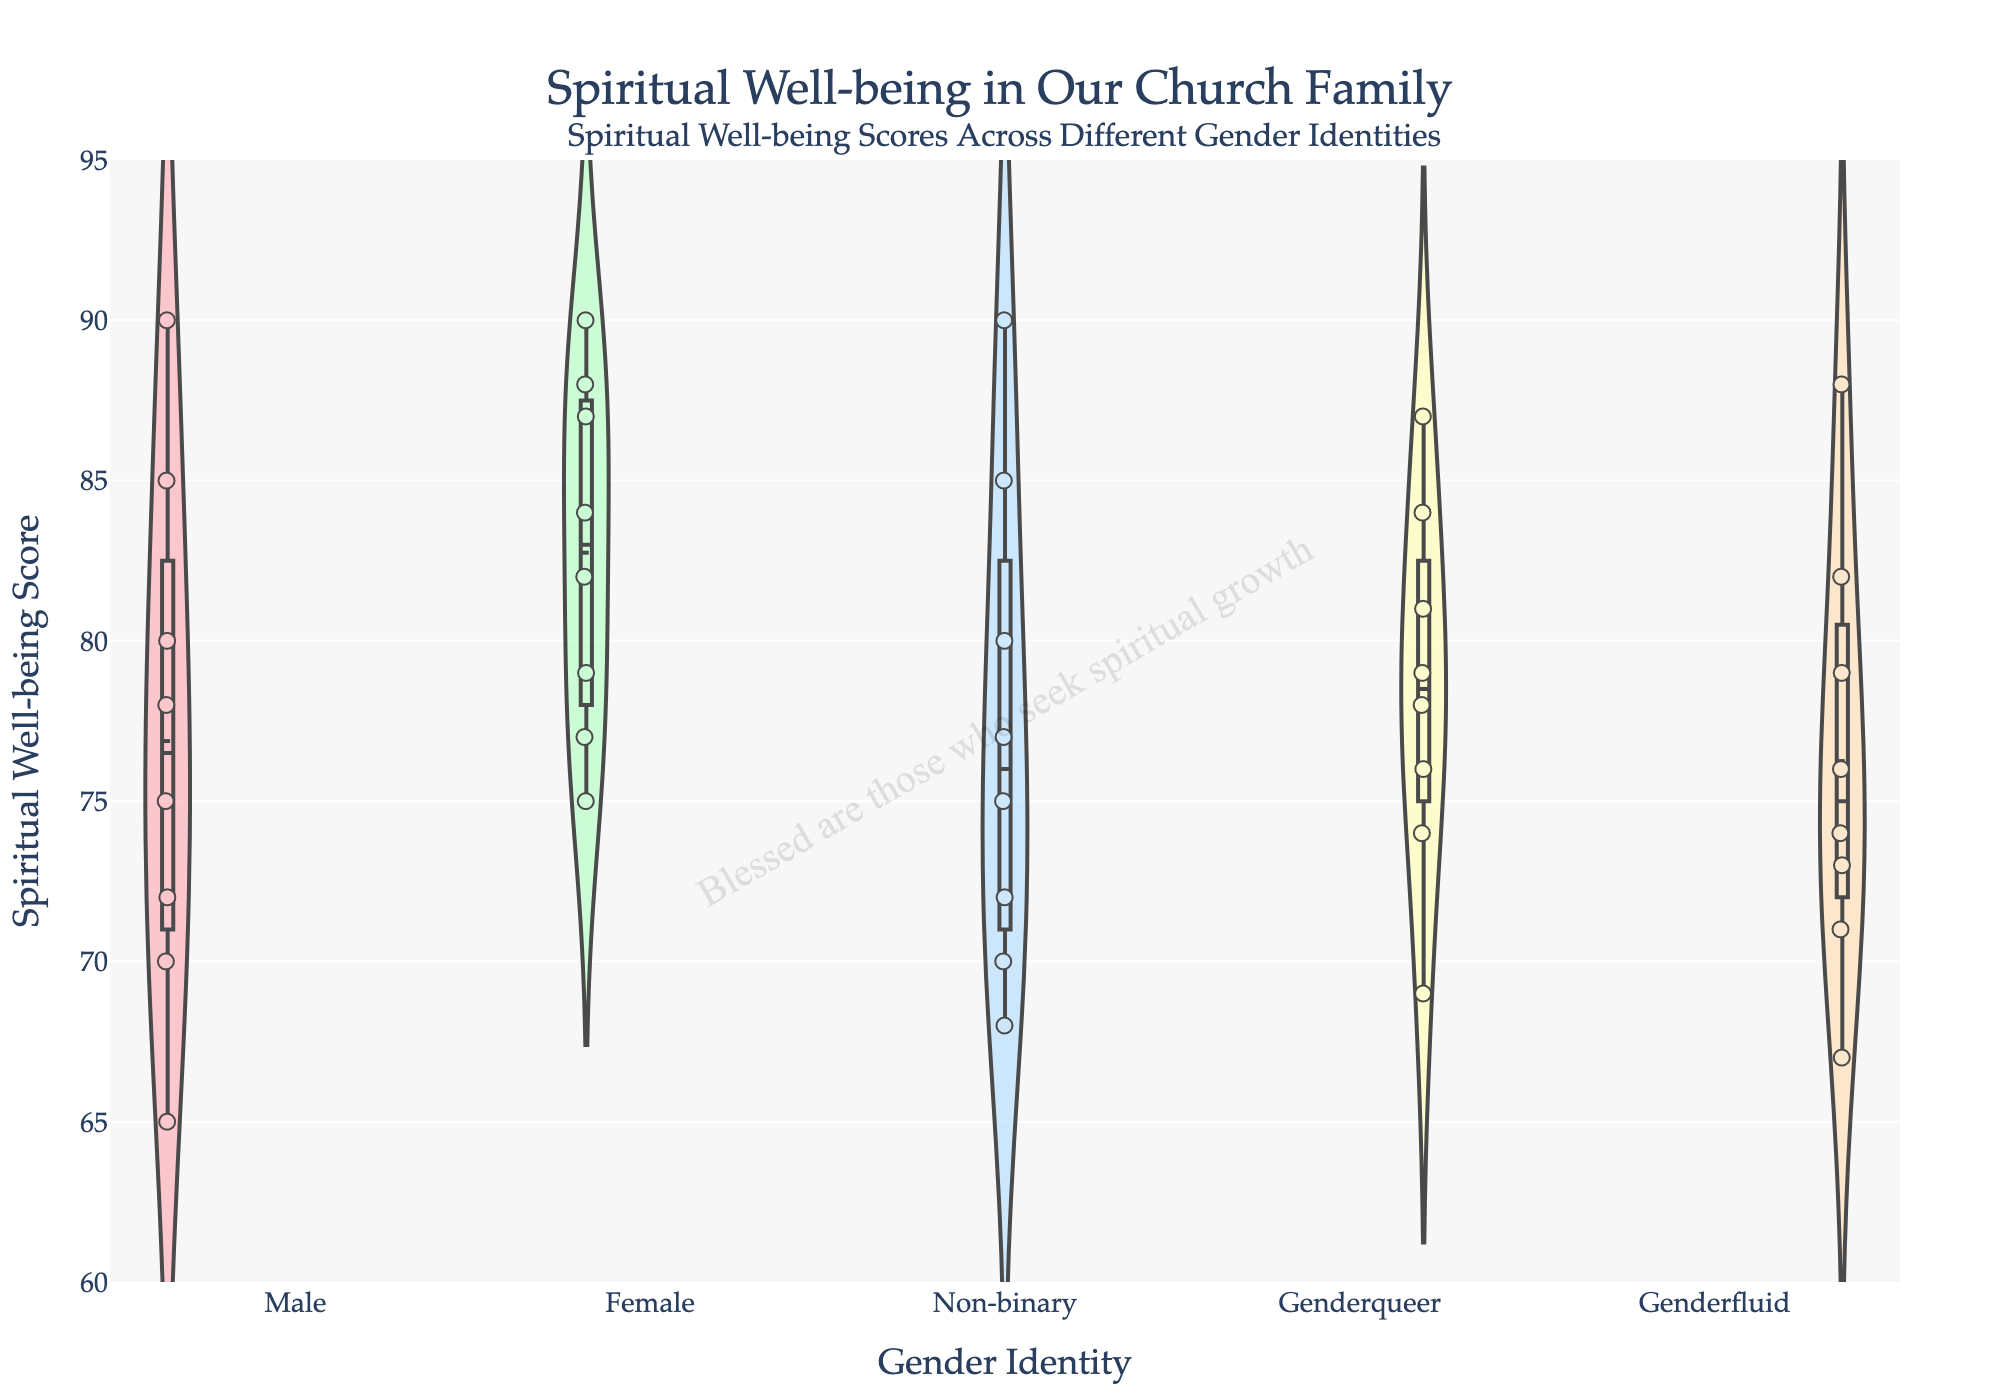What is the title of the plot? The title of the plot is located at the top and is a clear text string summarizing the content. It reads "Spiritual Well-being in Our Church Family."
Answer: Spiritual Well-being in Our Church Family What is the y-axis range for the spiritual well-being scores? The y-axis range is indicated on the left side of the plot, which shows it spans from 60 to 95.
Answer: 60 to 95 Which gender identity has the highest spiritual well-being score? By looking at the topmost data points in each violin plot, Non-binary and Female have the highest scores touching 90.
Answer: Non-binary and Female Which gender identity has the lowest average spiritual well-being score? To determine the lowest average, one must examine the mean lines across the violin plots. The Male category has the lowest mean line compared to others.
Answer: Male What is the range of spiritual well-being scores for Genderfluid individuals? The range can be found by looking at the top (maximum) and bottom (minimum) points within the Genderfluid violin plot. It ranges from 67 to 88.
Answer: 67 to 88 Which group shows the greatest spread in spiritual well-being scores? The spread can be assessed by comparing the height of the violin plots. Male and Non-binary show the greatest variations from 65 to 90 and 68 to 90, respectively.
Answer: Male and Non-binary How are the gender identities represented in the plot visually different? Each gender identity in the plot is visually distinguished by different color shades, with each violin plot having a unique color.
Answer: Different color shades for each gender Which gender identity has the smallest interquartile range (IQR) for spiritual well-being scores? The IQR is the distance between the box boundaries within each violin plot. Genderqueer has the smallest visible box, indicating the smallest IQR.
Answer: Genderqueer Are outliers visible for any of the gender identities? To determine this, one must check if there are individual points that fall far outside the bulk of the data within the violin plots. No significant outliers are visibly separated from the rest.
Answer: No significant outliers What is the average spiritual well-being score for Genderqueer individuals? The average is indicated by the mean line in each violin plot. The Genderqueer mean line is approximately around 75-77.
Answer: Approximately 75-77 